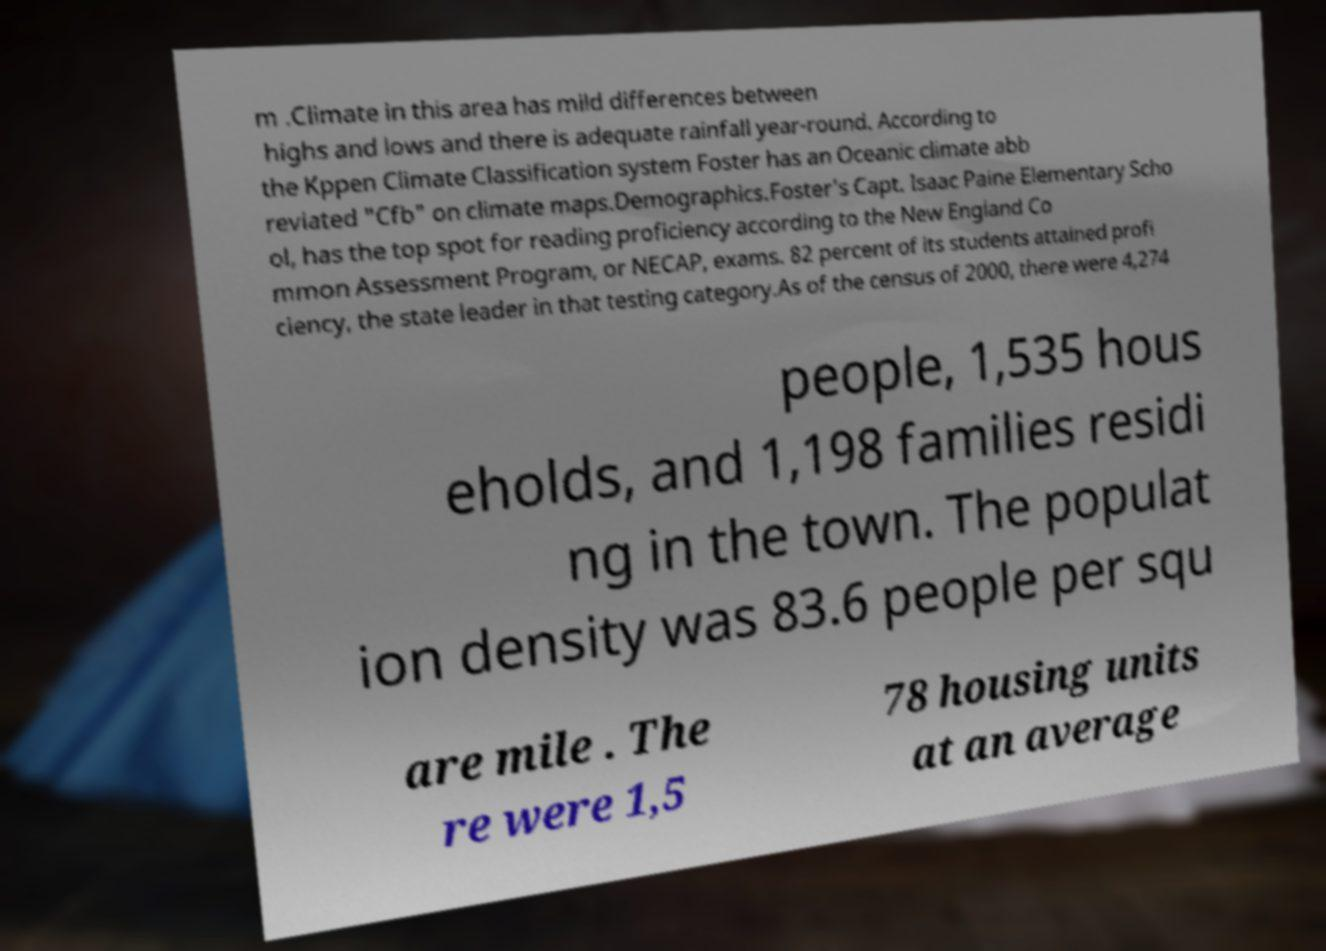Could you extract and type out the text from this image? m .Climate in this area has mild differences between highs and lows and there is adequate rainfall year-round. According to the Kppen Climate Classification system Foster has an Oceanic climate abb reviated "Cfb" on climate maps.Demographics.Foster's Capt. Isaac Paine Elementary Scho ol, has the top spot for reading proficiency according to the New England Co mmon Assessment Program, or NECAP, exams. 82 percent of its students attained profi ciency, the state leader in that testing category.As of the census of 2000, there were 4,274 people, 1,535 hous eholds, and 1,198 families residi ng in the town. The populat ion density was 83.6 people per squ are mile . The re were 1,5 78 housing units at an average 